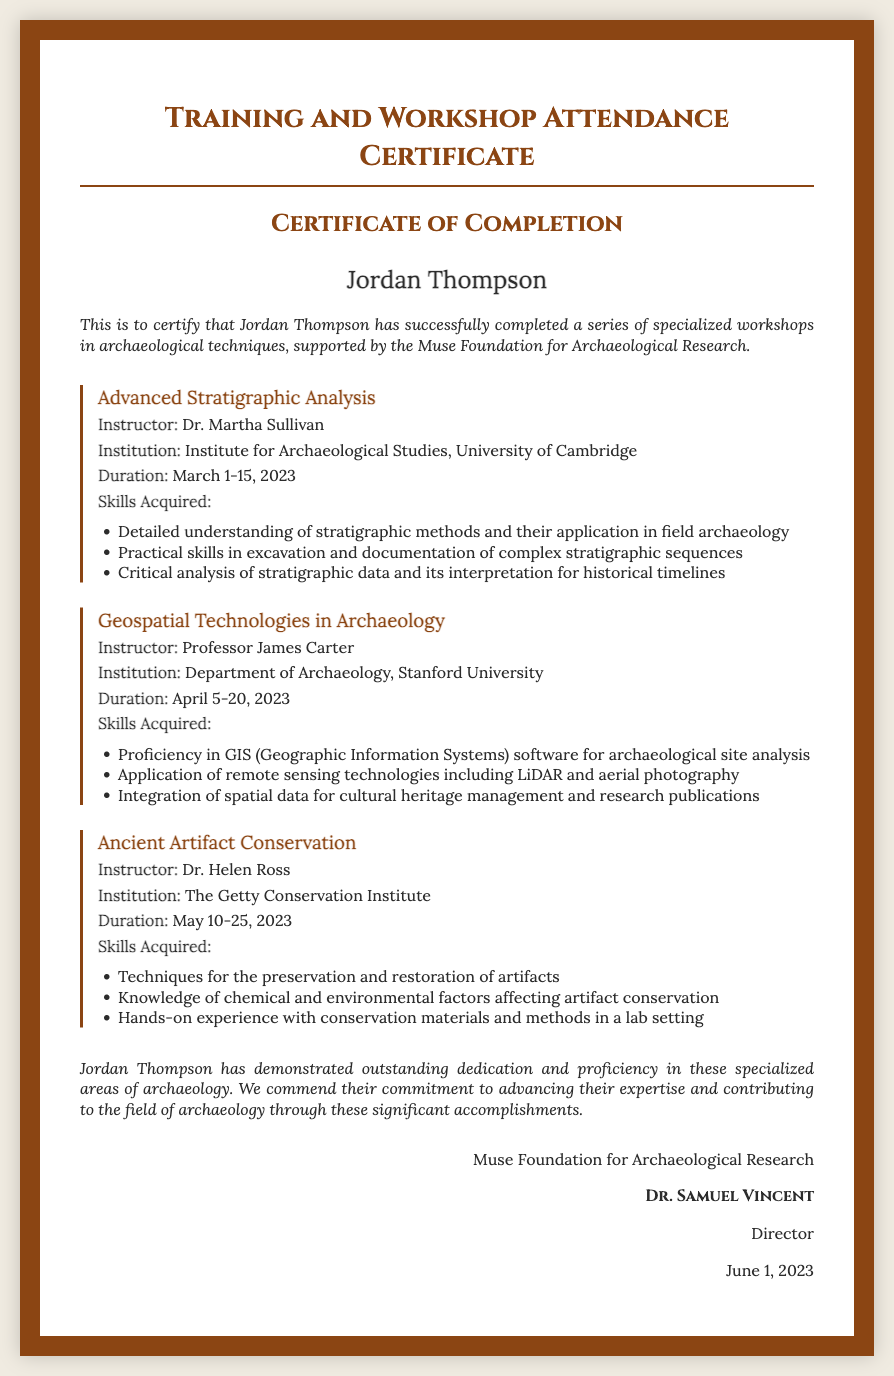What is the name of the recipient? The document states that the certificate is awarded to Jordan Thompson.
Answer: Jordan Thompson Who was the instructor for the Advanced Stratigraphic Analysis workshop? The document lists Dr. Martha Sullivan as the instructor for this workshop.
Answer: Dr. Martha Sullivan What is the duration of the Ancient Artifact Conservation workshop? According to the document, this workshop lasted from May 10-25, 2023.
Answer: May 10-25, 2023 Which institution conducted the Geospatial Technologies in Archaeology workshop? The document indicates that this workshop was conducted by Stanford University.
Answer: Stanford University List one skill acquired in the Advanced Stratigraphic Analysis workshop. The document provides several skills, one of which is a detailed understanding of stratigraphic methods.
Answer: Detailed understanding of stratigraphic methods How many workshops did Jordan Thompson complete? The document mentions that Jordan Thompson successfully completed a series of specialized workshops, specifically three workshops in total.
Answer: Three What endorsement is given to Jordan Thompson in the document? The document commends Jordan Thompson for outstanding dedication and proficiency in specialized areas of archaeology.
Answer: Outstanding dedication and proficiency Who issued the certificate? The document states that the certificate was issued by the Muse Foundation for Archaeological Research.
Answer: Muse Foundation for Archaeological Research What is the date of issuance for the certificate? The document indicates that the certificate was issued on June 1, 2023.
Answer: June 1, 2023 